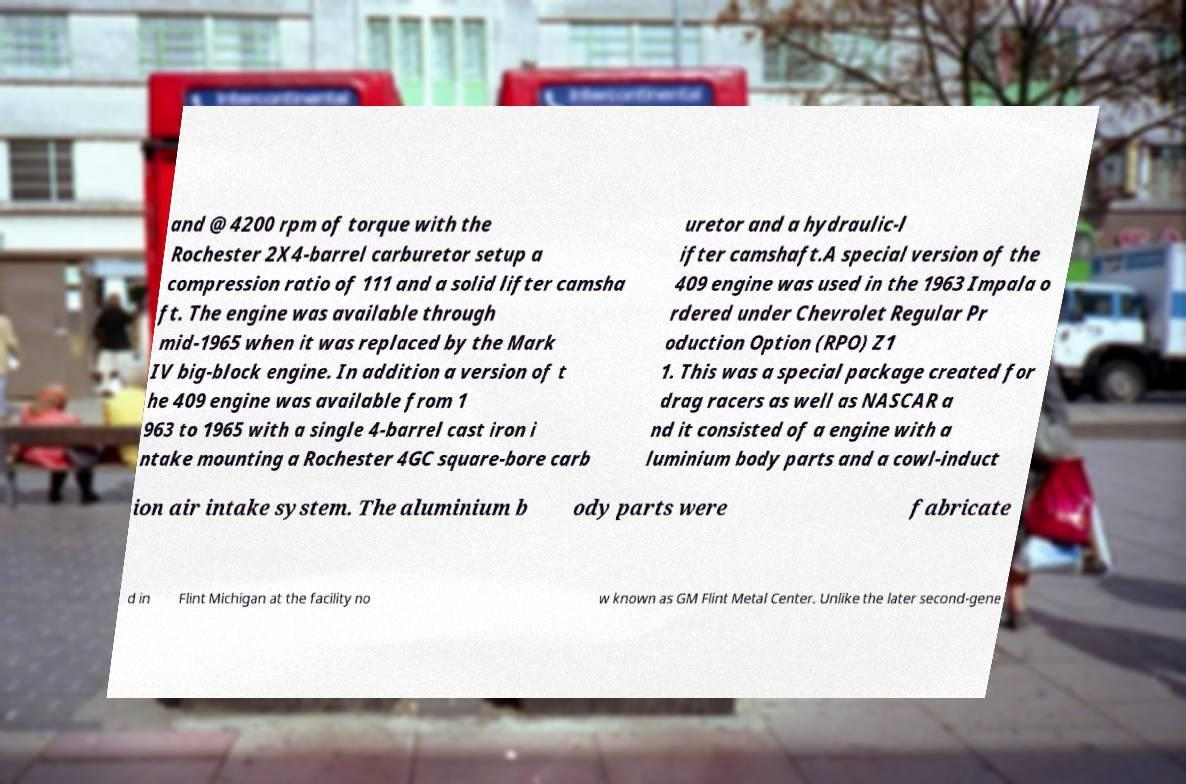Can you accurately transcribe the text from the provided image for me? and @ 4200 rpm of torque with the Rochester 2X4-barrel carburetor setup a compression ratio of 111 and a solid lifter camsha ft. The engine was available through mid-1965 when it was replaced by the Mark IV big-block engine. In addition a version of t he 409 engine was available from 1 963 to 1965 with a single 4-barrel cast iron i ntake mounting a Rochester 4GC square-bore carb uretor and a hydraulic-l ifter camshaft.A special version of the 409 engine was used in the 1963 Impala o rdered under Chevrolet Regular Pr oduction Option (RPO) Z1 1. This was a special package created for drag racers as well as NASCAR a nd it consisted of a engine with a luminium body parts and a cowl-induct ion air intake system. The aluminium b ody parts were fabricate d in Flint Michigan at the facility no w known as GM Flint Metal Center. Unlike the later second-gene 